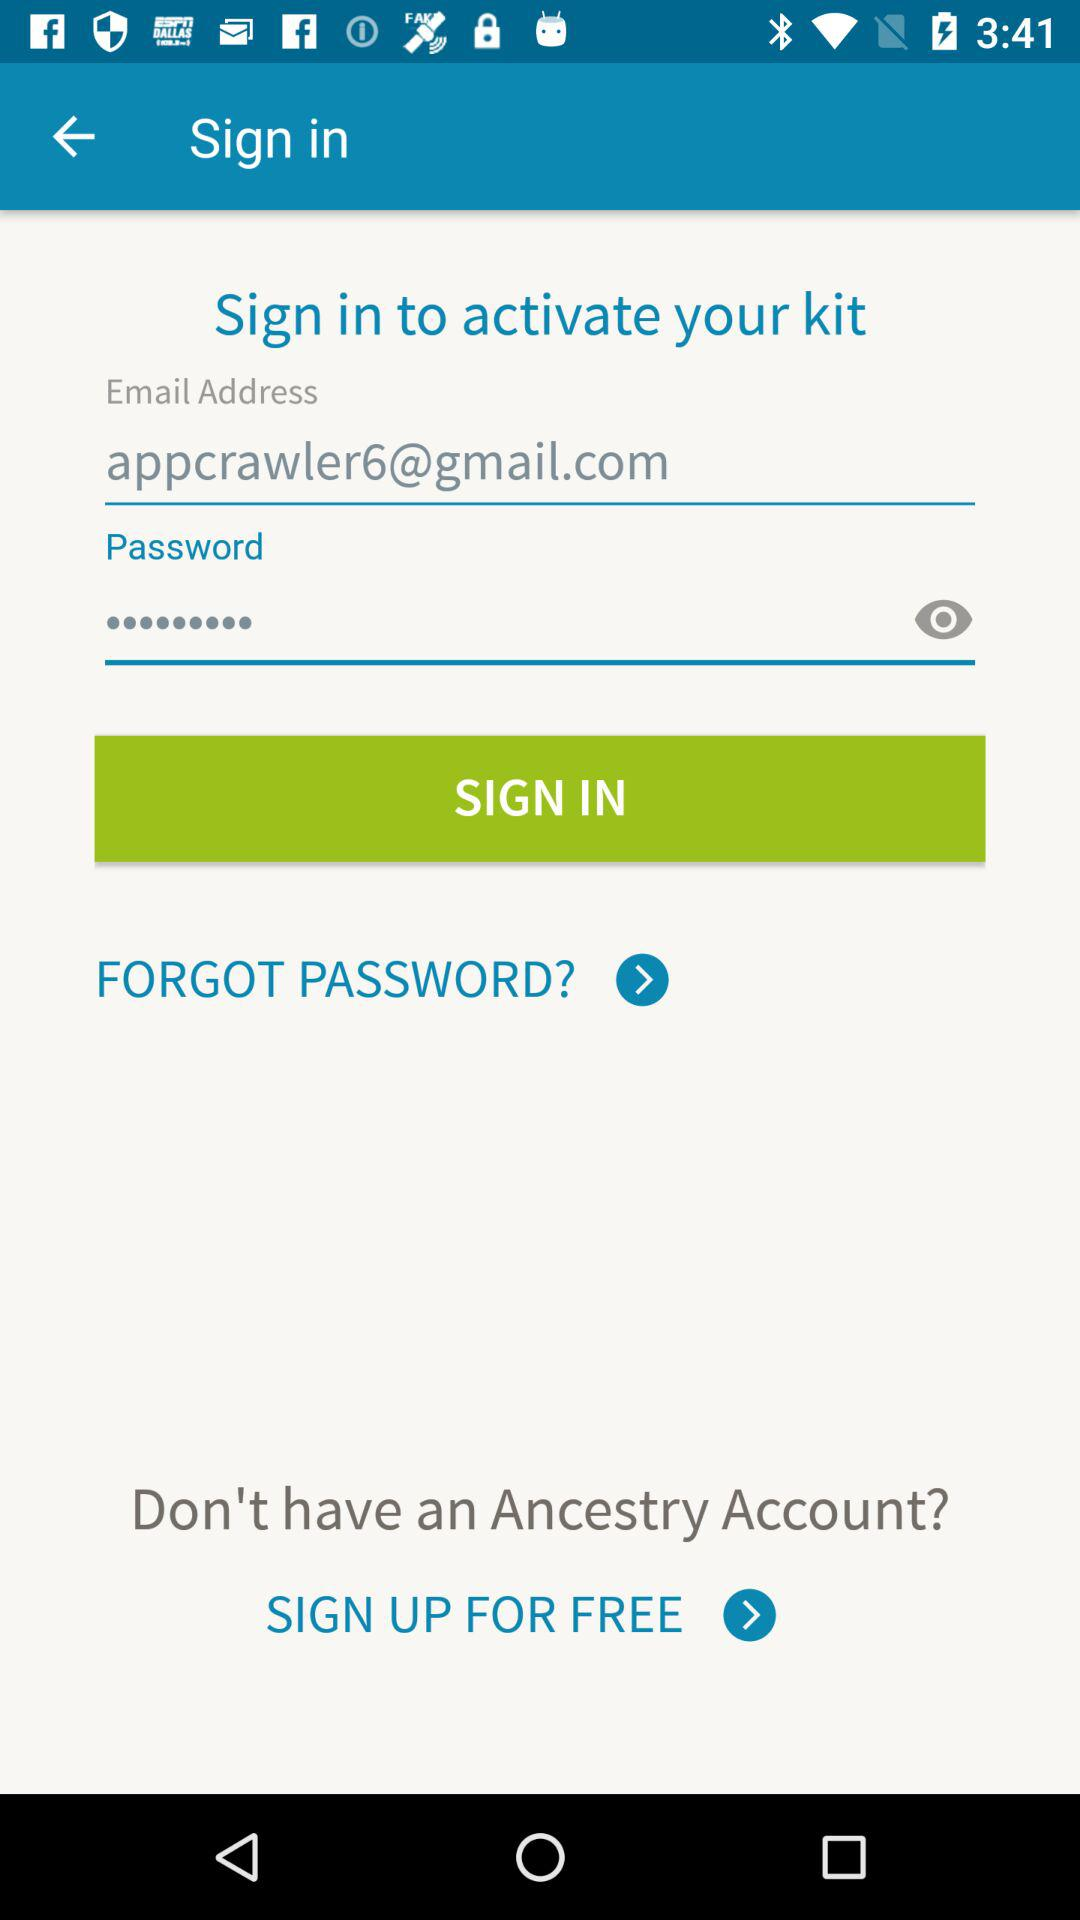What is the given email address? The given email address is appcrawler6@gmail.com. 